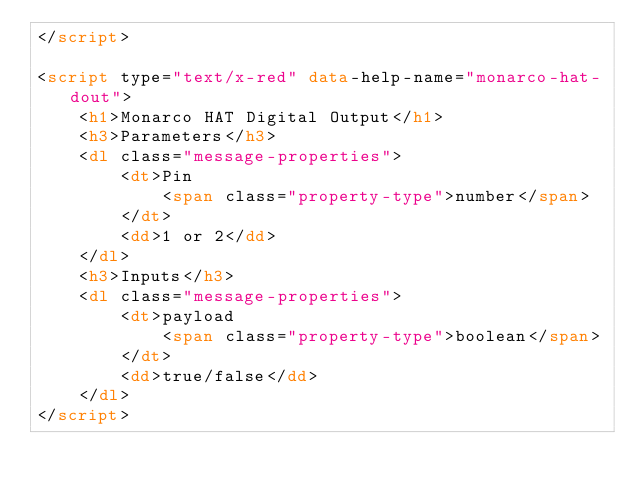Convert code to text. <code><loc_0><loc_0><loc_500><loc_500><_HTML_></script>

<script type="text/x-red" data-help-name="monarco-hat-dout">
    <h1>Monarco HAT Digital Output</h1>
    <h3>Parameters</h3>
    <dl class="message-properties">
        <dt>Pin
            <span class="property-type">number</span>
        </dt>
        <dd>1 or 2</dd>
    </dl>
    <h3>Inputs</h3>
    <dl class="message-properties">
        <dt>payload
            <span class="property-type">boolean</span>
        </dt>
        <dd>true/false</dd>
    </dl>
</script></code> 